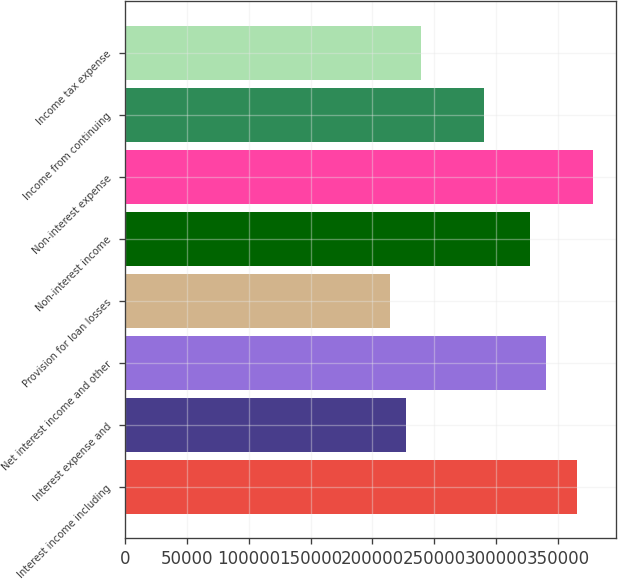<chart> <loc_0><loc_0><loc_500><loc_500><bar_chart><fcel>Interest income including<fcel>Interest expense and<fcel>Net interest income and other<fcel>Provision for loan losses<fcel>Non-interest income<fcel>Non-interest expense<fcel>Income from continuing<fcel>Income tax expense<nl><fcel>365544<fcel>226889<fcel>340334<fcel>214284<fcel>327729<fcel>378148<fcel>289914<fcel>239494<nl></chart> 